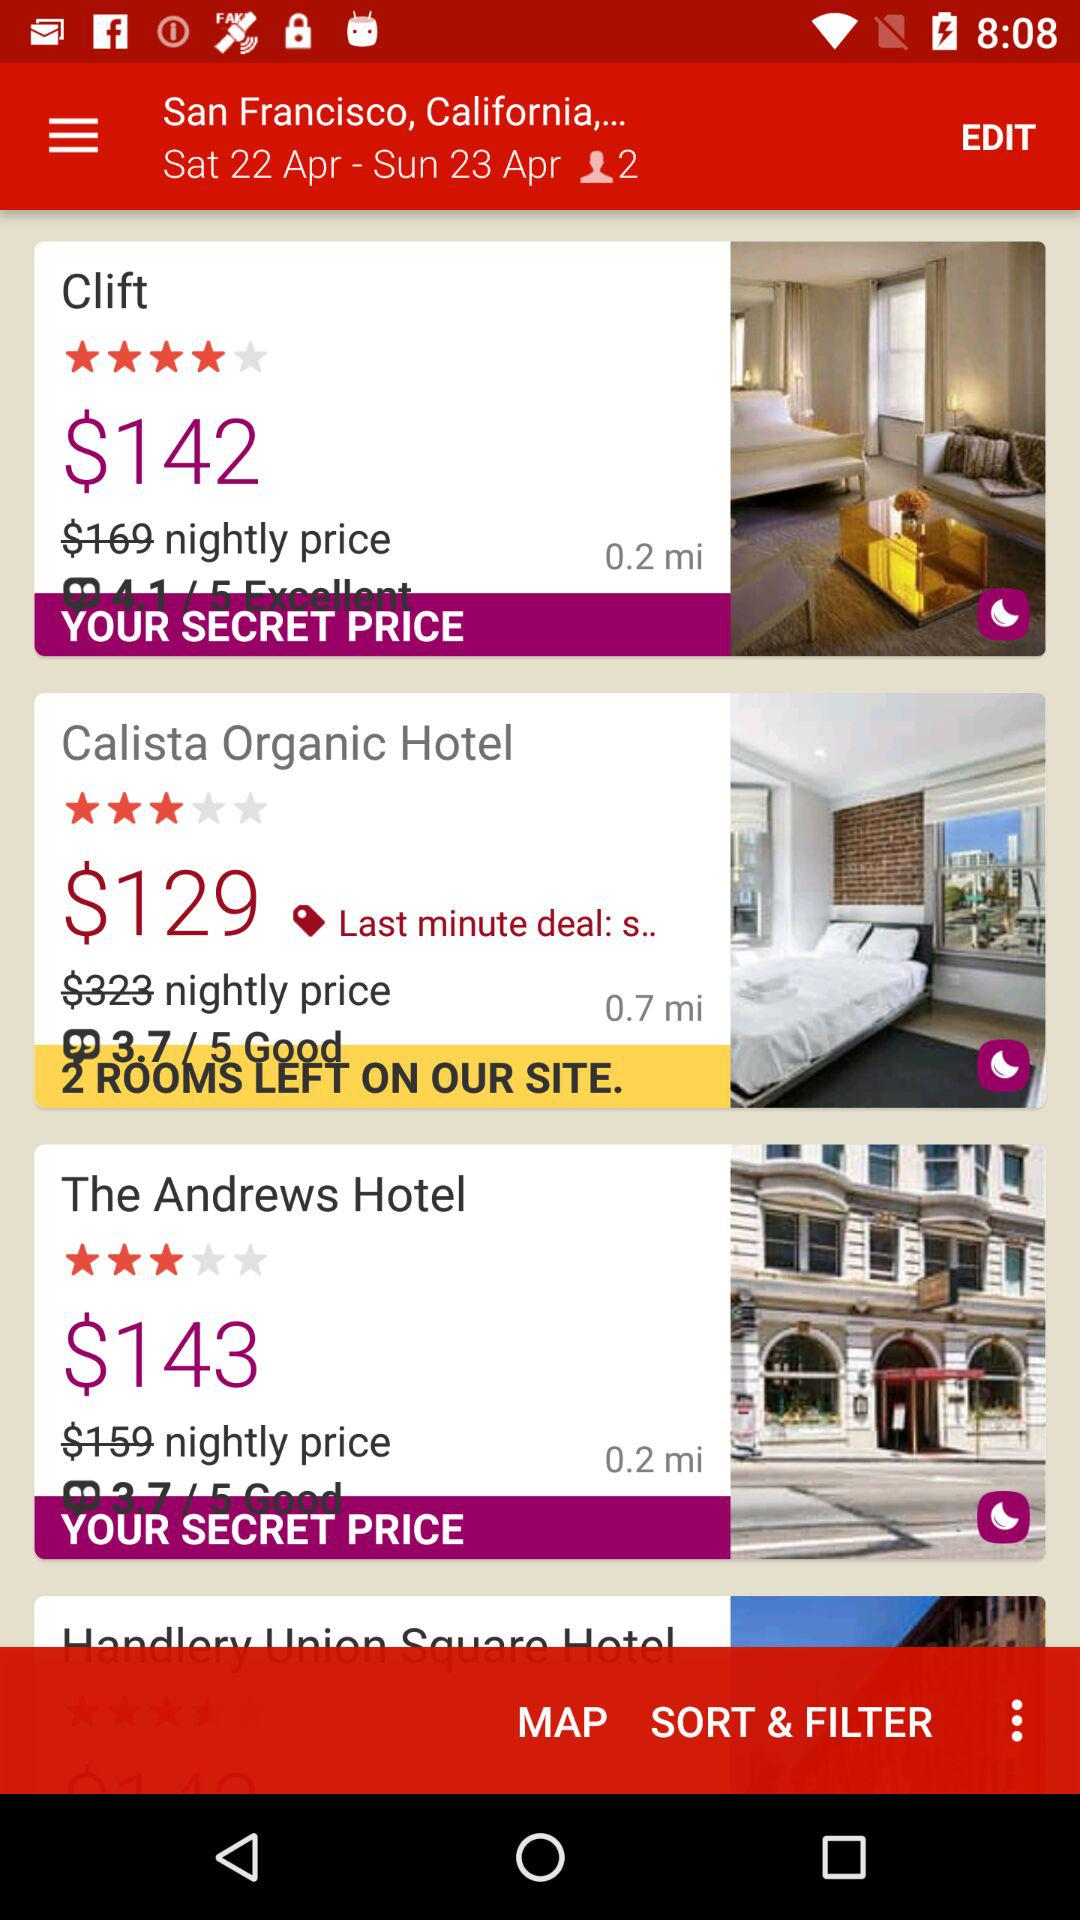How many rooms are left in the "Calista Organic Hotel"? There are 2 rooms left. 